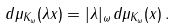<formula> <loc_0><loc_0><loc_500><loc_500>d \mu _ { K _ { \omega } } ( \lambda x ) = | \lambda | _ { \omega } \, d \mu _ { K _ { \omega } } ( x ) \, .</formula> 